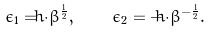Convert formula to latex. <formula><loc_0><loc_0><loc_500><loc_500>\epsilon _ { 1 } = \hbar { \cdot } \beta ^ { \frac { 1 } { 2 } } , \quad \epsilon _ { 2 } = - \hbar { \cdot } \beta ^ { - \frac { 1 } { 2 } } .</formula> 